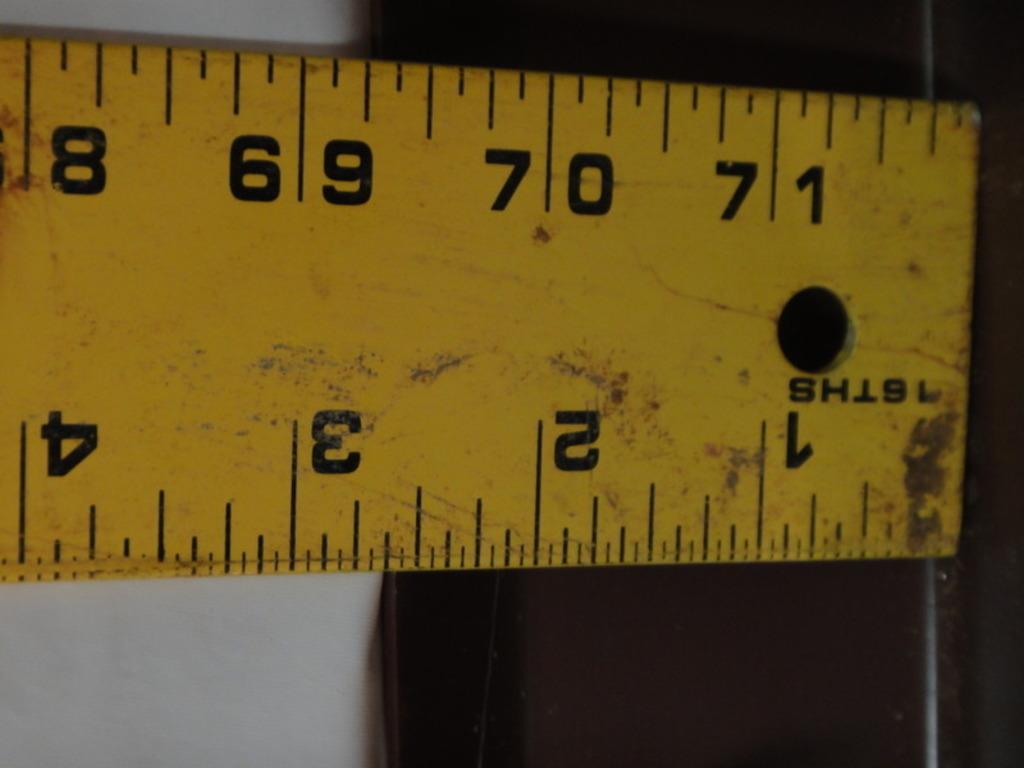What's the highest number on the ruler?
Make the answer very short. 71. How many inches are shown?
Give a very brief answer. 71. 